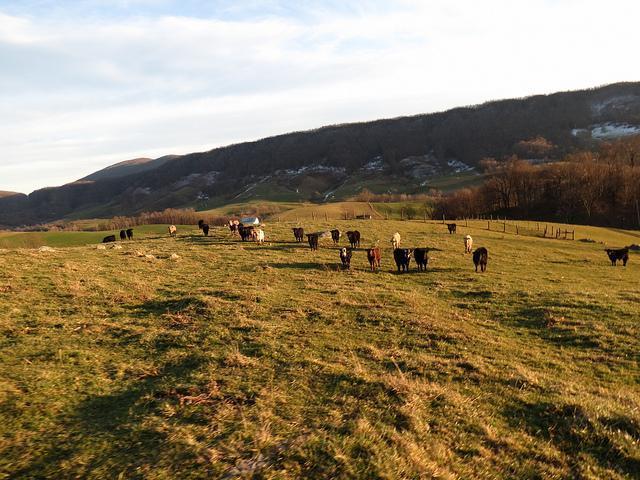How many horses are there?
Give a very brief answer. 0. 